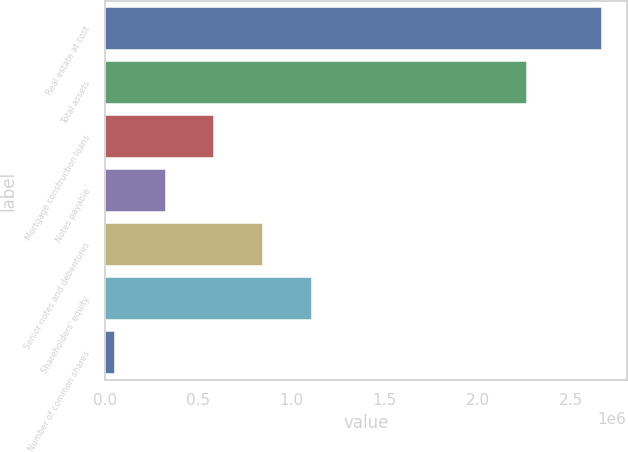Convert chart. <chart><loc_0><loc_0><loc_500><loc_500><bar_chart><fcel>Real estate at cost<fcel>Total assets<fcel>Mortgage construction loans<fcel>Notes payable<fcel>Senior notes and debentures<fcel>Shareholders' equity<fcel>Number of common shares<nl><fcel>2.66628e+06<fcel>2.2669e+06<fcel>586465<fcel>325051<fcel>847879<fcel>1.10929e+06<fcel>52137<nl></chart> 